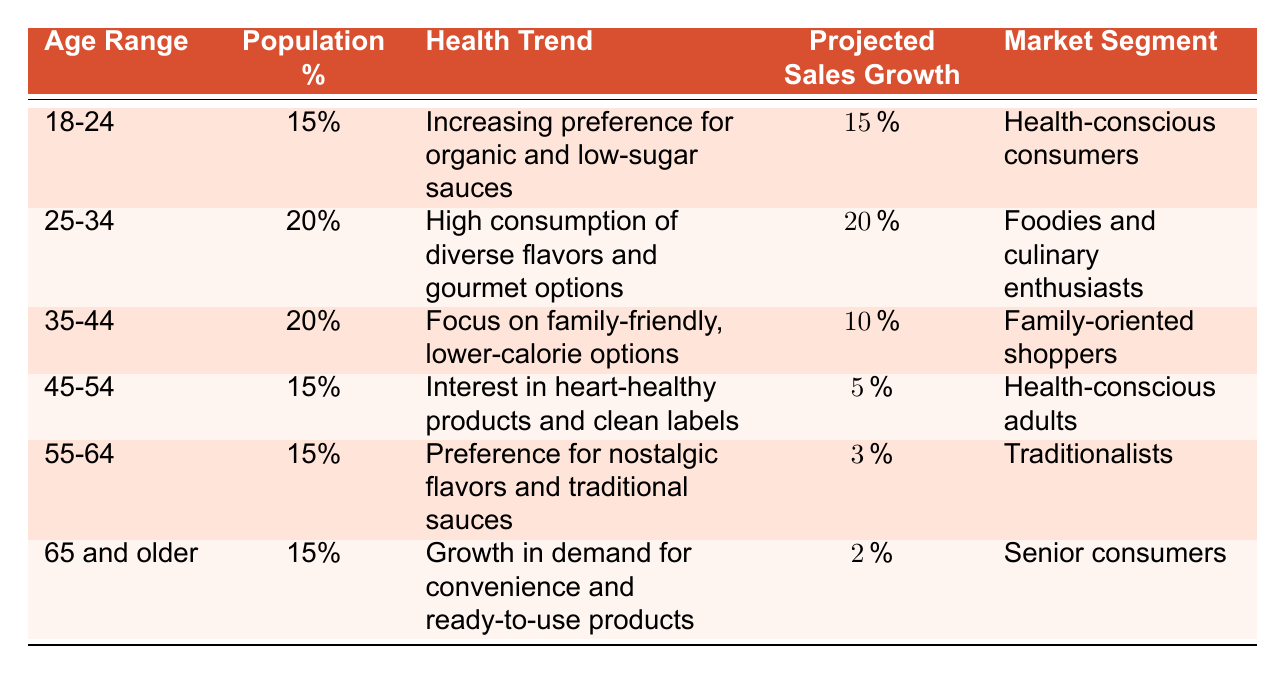What is the projected sales growth for the age group 18-24? The projected sales growth for the age group 18-24 is explicitly listed in the table as 15 percent.
Answer: 15 percent What health trend is associated with the age range 35-44? The table shows that the health trend for the age range 35-44 is a focus on family-friendly, lower-calorie options.
Answer: Focus on family-friendly, lower-calorie options Which age group has the highest projected sales growth? By comparing the projected sales growth values in the table, the 25-34 age group shows the highest growth at 20 percent.
Answer: 25-34 age group What is the total population percentage of the 45-54 and 55-64 age groups combined? The populations for the 45-54 and 55-64 age groups are 15 percent and 15 percent, respectively. Adding these gives a total of 15 + 15 = 30 percent.
Answer: 30 percent Is there a demographic trend for the 65 and older age group towards health-conscious options? The table indicates that the health trend for the 65 and older age group is centered on convenience and ready-to-use products, which suggests a lower focus on health-conscious options. Therefore, the statement is false.
Answer: No What percentage of the total population do the age groups 18-24 and 25-34 represent collectively? The table shows that the population percentage for 18-24 is 15 percent and for 25-34 is 20 percent. Combined, they total 15 + 20 = 35 percent.
Answer: 35 percent Is the projected sales growth for the traditionalists (55-64 age group) less than the growth for family-oriented shoppers (35-44 age group)? The projected sales growth for traditionalists is 3 percent, while for family-oriented shoppers, it is 10 percent. Since 3 is less than 10, the statement is true.
Answer: Yes Which market segment has the lowest projected sales growth? By reviewing the projected sales growth for each market segment, the senior consumers (65 and older) have the lowest projected sales growth at 2 percent.
Answer: Senior consumers What is the average projected sales growth across all age groups? Adding the projected sales growth percentages: 15 + 20 + 10 + 5 + 3 + 2 = 55. There are six age groups; thus, the average growth is 55 / 6 = approximately 9.17 percent.
Answer: 9.17 percent 